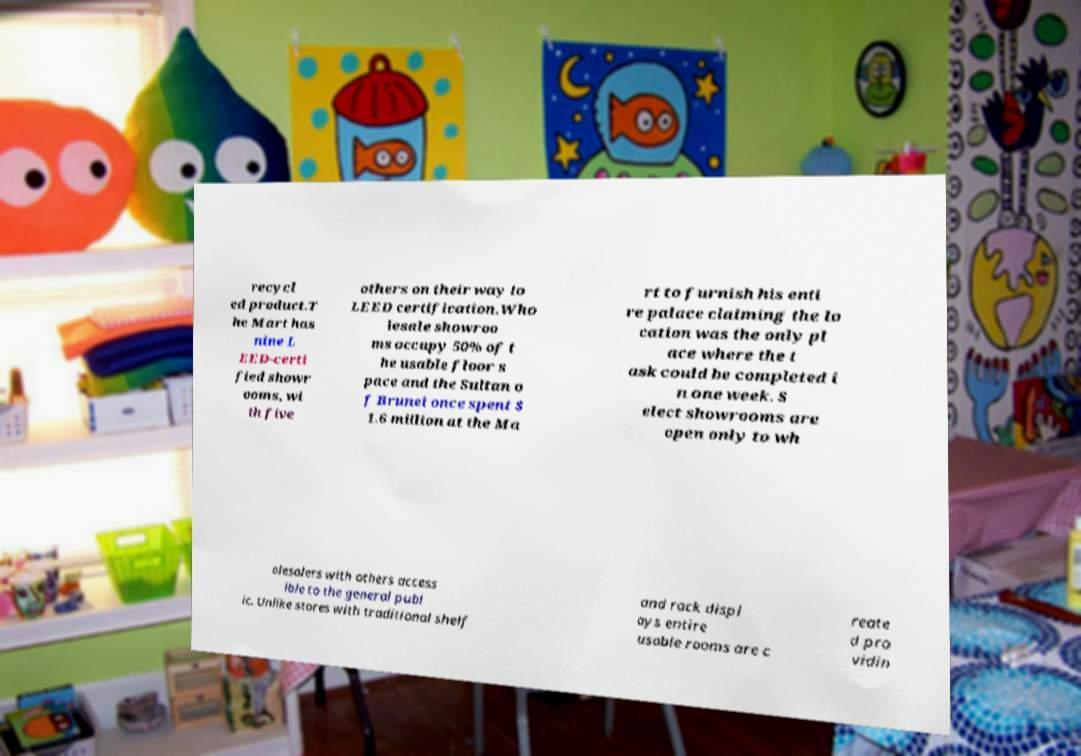For documentation purposes, I need the text within this image transcribed. Could you provide that? recycl ed product.T he Mart has nine L EED-certi fied showr ooms, wi th five others on their way to LEED certification.Who lesale showroo ms occupy 50% of t he usable floor s pace and the Sultan o f Brunei once spent $ 1.6 million at the Ma rt to furnish his enti re palace claiming the lo cation was the only pl ace where the t ask could be completed i n one week. S elect showrooms are open only to wh olesalers with others access ible to the general publ ic. Unlike stores with traditional shelf and rack displ ays entire usable rooms are c reate d pro vidin 